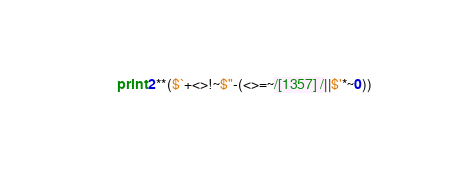Convert code to text. <code><loc_0><loc_0><loc_500><loc_500><_Perl_>print 2**($`+<>!~$"-(<>=~/[1357] /||$'*~0))</code> 